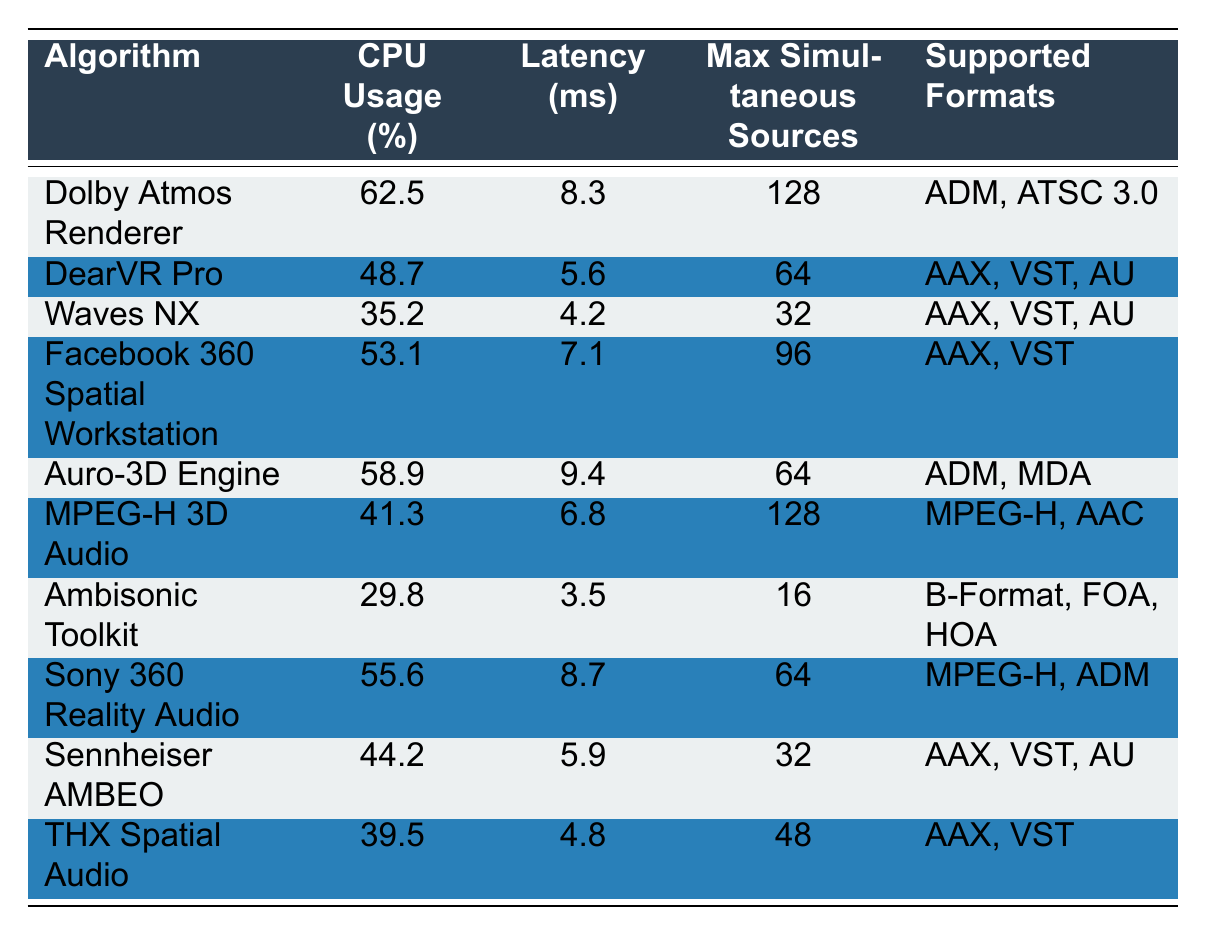What is the CPU usage of the Dolby Atmos Renderer? The table lists the CPU usage percentage for each algorithm. The value associated with the Dolby Atmos Renderer is 62.5%.
Answer: 62.5% Which algorithm has the lowest CPU usage? By examining the CPU Usage column, the lowest value is 29.8%, corresponding to the Ambisonic Toolkit.
Answer: Ambisonic Toolkit What is the maximum number of simultaneous sources supported by the Auro-3D Engine? The table provides the maximum simultaneous sources for each algorithm. The Auro-3D Engine supports 64 sources.
Answer: 64 What is the average latency of all algorithms listed in the table? First, sum all the latency values: 8.3 + 5.6 + 4.2 + 7.1 + 9.4 + 6.8 + 3.5 + 8.7 + 5.9 + 4.8 = 63.3 ms. There are 10 algorithms, so the average latency is 63.3 / 10 = 6.33 ms.
Answer: 6.33 ms Which algorithm has both the highest CPU usage and the maximum number of simultaneous sources? The table shows the Dolby Atmos Renderer has the highest CPU usage at 62.5% and supports 128 simultaneous sources.
Answer: Dolby Atmos Renderer Is the DearVR Pro compatible with the AAX format? The Supported Formats column states that DearVR Pro is compatible with AAX.
Answer: Yes What is the CPU usage difference between Waves NX and Sony 360 Reality Audio? The CPU usage for Waves NX is 35.2% and for Sony 360 Reality Audio it is 55.6%. The difference is 55.6 - 35.2 = 20.4%.
Answer: 20.4% Which algorithms have a latency lower than 6 ms? By checking the Latency column, the algorithms with latency lower than 6 ms are Waves NX (4.2 ms), and Ambisonic Toolkit (3.5 ms).
Answer: Waves NX, Ambisonic Toolkit What is the total of the maximum simultaneous sources for all algorithms? The maximum simultaneous sources for each algorithm are: 128, 64, 32, 96, 64, 128, 16, 64, 32, 48. Adding these gives: 128 + 64 + 32 + 96 + 64 + 128 + 16 + 64 + 32 + 48 = 672.
Answer: 672 Does the MPEG-H 3D Audio algorithm support AAX format? The Supported Formats for MPEG-H 3D Audio are listed as MPEG-H and AAC; AAX is not included.
Answer: No 